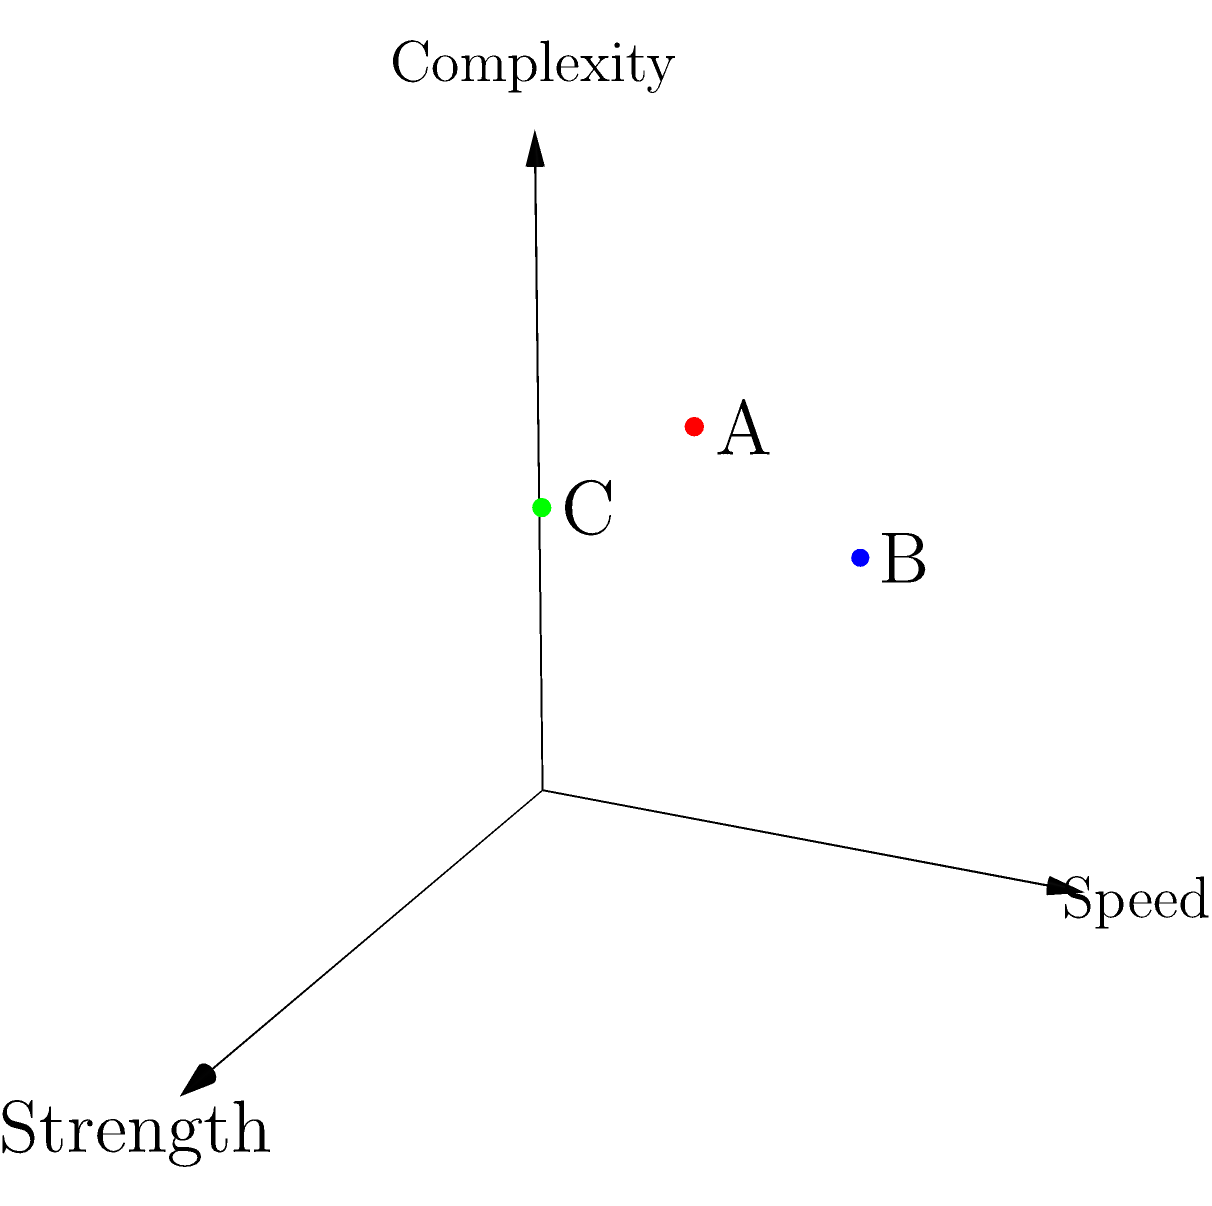In the 3D coordinate system shown, three encryption algorithms (A, B, and C) are represented as vectors based on their strength, speed, and complexity. Which algorithm offers the best balance of all three attributes, as measured by the Euclidean distance from the origin (0,0,0)? To determine which algorithm offers the best balance of all three attributes, we need to calculate the Euclidean distance from the origin (0,0,0) for each algorithm. The algorithm with the largest distance will be considered the most balanced.

Step 1: Recall the formula for Euclidean distance in 3D space:
$$d = \sqrt{x^2 + y^2 + z^2}$$

Step 2: Calculate the distance for Algorithm A (red dot):
$$d_A = \sqrt{0.8^2 + 0.7^2 + 0.9^2} = \sqrt{0.64 + 0.49 + 0.81} = \sqrt{1.94} \approx 1.39$$

Step 3: Calculate the distance for Algorithm B (blue dot):
$$d_B = \sqrt{0.6^2 + 0.9^2 + 0.7^2} = \sqrt{0.36 + 0.81 + 0.49} = \sqrt{1.66} \approx 1.29$$

Step 4: Calculate the distance for Algorithm C (green dot):
$$d_C = \sqrt{0.9^2 + 0.5^2 + 0.8^2} = \sqrt{0.81 + 0.25 + 0.64} = \sqrt{1.70} \approx 1.30$$

Step 5: Compare the distances:
$d_A \approx 1.39$
$d_B \approx 1.29$
$d_C \approx 1.30$

Algorithm A has the largest distance from the origin, indicating the best balance of all three attributes.
Answer: Algorithm A 